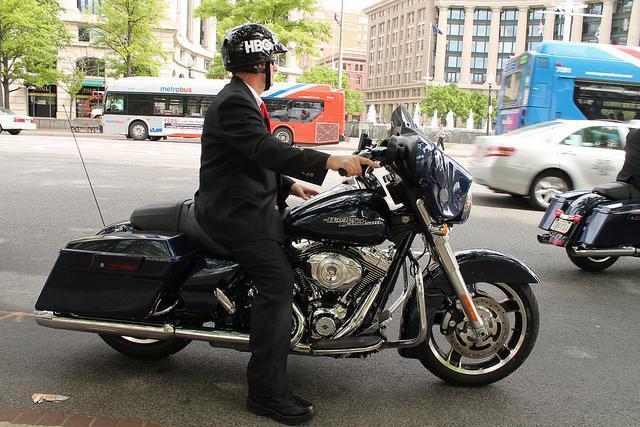How many cars are there?
Give a very brief answer. 2. How many buses can you see?
Give a very brief answer. 2. How many motorcycles are visible?
Give a very brief answer. 2. 